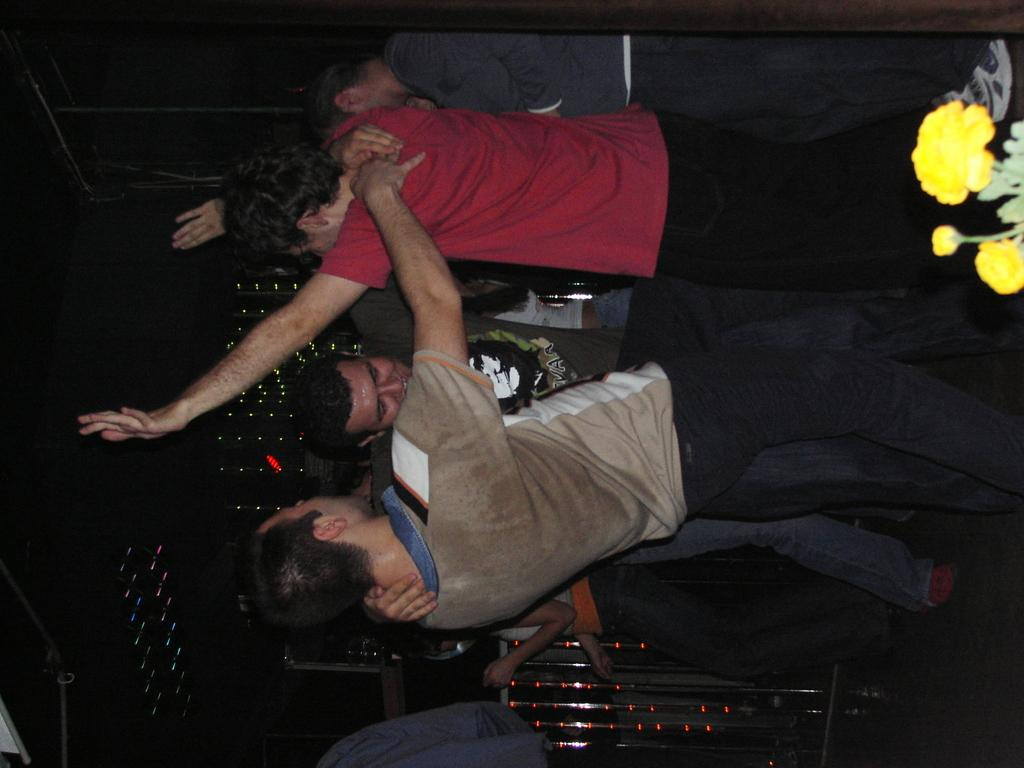Who or what is present in the image? There are people in the image. Where are the people located? The people are in a room. What are the people doing in the image? The people appear to be dancing. What can be seen on the right side of the image? There are flowers on the right side of the image. Can you see any ghosts in the image? There are no ghosts present in the image. What type of monkey is sitting on the dancer's shoulder in the image? There are no monkeys present in the image; the people appear to be dancing without any animals. 